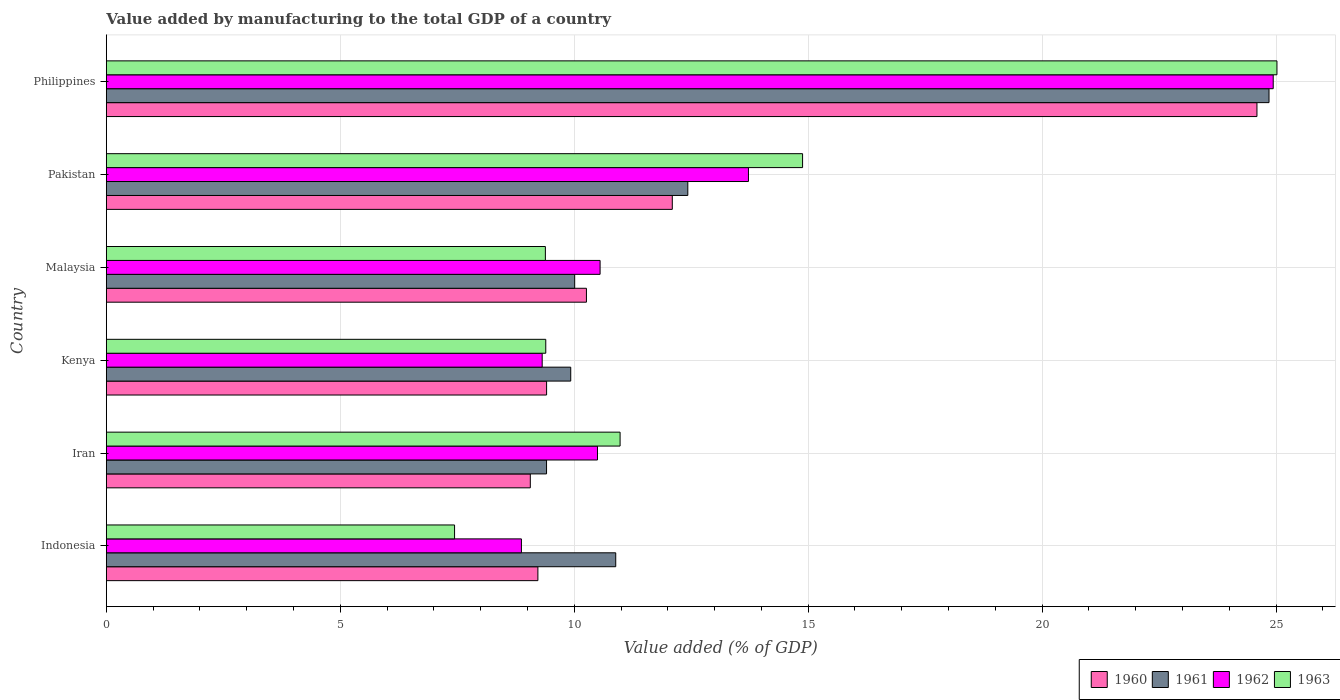How many groups of bars are there?
Keep it short and to the point. 6. How many bars are there on the 2nd tick from the top?
Make the answer very short. 4. What is the label of the 3rd group of bars from the top?
Keep it short and to the point. Malaysia. What is the value added by manufacturing to the total GDP in 1961 in Malaysia?
Make the answer very short. 10.01. Across all countries, what is the maximum value added by manufacturing to the total GDP in 1960?
Ensure brevity in your answer.  24.59. Across all countries, what is the minimum value added by manufacturing to the total GDP in 1961?
Provide a short and direct response. 9.41. In which country was the value added by manufacturing to the total GDP in 1960 maximum?
Your answer should be compact. Philippines. In which country was the value added by manufacturing to the total GDP in 1960 minimum?
Offer a terse response. Iran. What is the total value added by manufacturing to the total GDP in 1962 in the graph?
Offer a very short reply. 77.9. What is the difference between the value added by manufacturing to the total GDP in 1963 in Pakistan and that in Philippines?
Give a very brief answer. -10.14. What is the difference between the value added by manufacturing to the total GDP in 1963 in Iran and the value added by manufacturing to the total GDP in 1962 in Philippines?
Keep it short and to the point. -13.96. What is the average value added by manufacturing to the total GDP in 1961 per country?
Give a very brief answer. 12.92. What is the difference between the value added by manufacturing to the total GDP in 1963 and value added by manufacturing to the total GDP in 1962 in Philippines?
Ensure brevity in your answer.  0.08. In how many countries, is the value added by manufacturing to the total GDP in 1963 greater than 6 %?
Make the answer very short. 6. What is the ratio of the value added by manufacturing to the total GDP in 1962 in Pakistan to that in Philippines?
Ensure brevity in your answer.  0.55. What is the difference between the highest and the second highest value added by manufacturing to the total GDP in 1962?
Your answer should be very brief. 11.22. What is the difference between the highest and the lowest value added by manufacturing to the total GDP in 1963?
Ensure brevity in your answer.  17.58. Is it the case that in every country, the sum of the value added by manufacturing to the total GDP in 1963 and value added by manufacturing to the total GDP in 1961 is greater than the sum of value added by manufacturing to the total GDP in 1962 and value added by manufacturing to the total GDP in 1960?
Keep it short and to the point. No. What does the 1st bar from the top in Iran represents?
Keep it short and to the point. 1963. What does the 2nd bar from the bottom in Kenya represents?
Provide a succinct answer. 1961. Is it the case that in every country, the sum of the value added by manufacturing to the total GDP in 1960 and value added by manufacturing to the total GDP in 1961 is greater than the value added by manufacturing to the total GDP in 1963?
Provide a succinct answer. Yes. Are all the bars in the graph horizontal?
Your answer should be compact. Yes. What is the difference between two consecutive major ticks on the X-axis?
Your answer should be compact. 5. Are the values on the major ticks of X-axis written in scientific E-notation?
Offer a very short reply. No. Does the graph contain grids?
Your answer should be compact. Yes. Where does the legend appear in the graph?
Provide a succinct answer. Bottom right. How many legend labels are there?
Ensure brevity in your answer.  4. How are the legend labels stacked?
Keep it short and to the point. Horizontal. What is the title of the graph?
Make the answer very short. Value added by manufacturing to the total GDP of a country. Does "2000" appear as one of the legend labels in the graph?
Provide a succinct answer. No. What is the label or title of the X-axis?
Provide a succinct answer. Value added (% of GDP). What is the label or title of the Y-axis?
Provide a succinct answer. Country. What is the Value added (% of GDP) in 1960 in Indonesia?
Provide a succinct answer. 9.22. What is the Value added (% of GDP) of 1961 in Indonesia?
Your answer should be compact. 10.89. What is the Value added (% of GDP) in 1962 in Indonesia?
Your response must be concise. 8.87. What is the Value added (% of GDP) in 1963 in Indonesia?
Provide a short and direct response. 7.44. What is the Value added (% of GDP) in 1960 in Iran?
Provide a succinct answer. 9.06. What is the Value added (% of GDP) in 1961 in Iran?
Provide a short and direct response. 9.41. What is the Value added (% of GDP) in 1962 in Iran?
Your answer should be compact. 10.5. What is the Value added (% of GDP) of 1963 in Iran?
Ensure brevity in your answer.  10.98. What is the Value added (% of GDP) in 1960 in Kenya?
Offer a terse response. 9.41. What is the Value added (% of GDP) in 1961 in Kenya?
Give a very brief answer. 9.93. What is the Value added (% of GDP) of 1962 in Kenya?
Offer a very short reply. 9.32. What is the Value added (% of GDP) in 1963 in Kenya?
Give a very brief answer. 9.39. What is the Value added (% of GDP) of 1960 in Malaysia?
Provide a succinct answer. 10.26. What is the Value added (% of GDP) in 1961 in Malaysia?
Your response must be concise. 10.01. What is the Value added (% of GDP) in 1962 in Malaysia?
Your response must be concise. 10.55. What is the Value added (% of GDP) of 1963 in Malaysia?
Keep it short and to the point. 9.38. What is the Value added (% of GDP) of 1960 in Pakistan?
Keep it short and to the point. 12.1. What is the Value added (% of GDP) of 1961 in Pakistan?
Provide a succinct answer. 12.43. What is the Value added (% of GDP) of 1962 in Pakistan?
Ensure brevity in your answer.  13.72. What is the Value added (% of GDP) in 1963 in Pakistan?
Keep it short and to the point. 14.88. What is the Value added (% of GDP) of 1960 in Philippines?
Provide a succinct answer. 24.59. What is the Value added (% of GDP) in 1961 in Philippines?
Your answer should be compact. 24.85. What is the Value added (% of GDP) of 1962 in Philippines?
Your answer should be very brief. 24.94. What is the Value added (% of GDP) in 1963 in Philippines?
Your answer should be very brief. 25.02. Across all countries, what is the maximum Value added (% of GDP) of 1960?
Keep it short and to the point. 24.59. Across all countries, what is the maximum Value added (% of GDP) in 1961?
Keep it short and to the point. 24.85. Across all countries, what is the maximum Value added (% of GDP) of 1962?
Ensure brevity in your answer.  24.94. Across all countries, what is the maximum Value added (% of GDP) in 1963?
Your answer should be very brief. 25.02. Across all countries, what is the minimum Value added (% of GDP) of 1960?
Provide a succinct answer. 9.06. Across all countries, what is the minimum Value added (% of GDP) in 1961?
Keep it short and to the point. 9.41. Across all countries, what is the minimum Value added (% of GDP) in 1962?
Keep it short and to the point. 8.87. Across all countries, what is the minimum Value added (% of GDP) in 1963?
Your answer should be very brief. 7.44. What is the total Value added (% of GDP) of 1960 in the graph?
Ensure brevity in your answer.  74.64. What is the total Value added (% of GDP) in 1961 in the graph?
Make the answer very short. 77.51. What is the total Value added (% of GDP) of 1962 in the graph?
Your response must be concise. 77.9. What is the total Value added (% of GDP) of 1963 in the graph?
Offer a very short reply. 77.1. What is the difference between the Value added (% of GDP) in 1960 in Indonesia and that in Iran?
Give a very brief answer. 0.16. What is the difference between the Value added (% of GDP) of 1961 in Indonesia and that in Iran?
Ensure brevity in your answer.  1.48. What is the difference between the Value added (% of GDP) of 1962 in Indonesia and that in Iran?
Offer a terse response. -1.63. What is the difference between the Value added (% of GDP) in 1963 in Indonesia and that in Iran?
Your answer should be very brief. -3.54. What is the difference between the Value added (% of GDP) in 1960 in Indonesia and that in Kenya?
Make the answer very short. -0.19. What is the difference between the Value added (% of GDP) in 1961 in Indonesia and that in Kenya?
Offer a very short reply. 0.96. What is the difference between the Value added (% of GDP) in 1962 in Indonesia and that in Kenya?
Give a very brief answer. -0.44. What is the difference between the Value added (% of GDP) of 1963 in Indonesia and that in Kenya?
Provide a succinct answer. -1.95. What is the difference between the Value added (% of GDP) of 1960 in Indonesia and that in Malaysia?
Your answer should be very brief. -1.04. What is the difference between the Value added (% of GDP) of 1961 in Indonesia and that in Malaysia?
Your response must be concise. 0.88. What is the difference between the Value added (% of GDP) of 1962 in Indonesia and that in Malaysia?
Keep it short and to the point. -1.68. What is the difference between the Value added (% of GDP) in 1963 in Indonesia and that in Malaysia?
Your response must be concise. -1.94. What is the difference between the Value added (% of GDP) of 1960 in Indonesia and that in Pakistan?
Offer a very short reply. -2.87. What is the difference between the Value added (% of GDP) of 1961 in Indonesia and that in Pakistan?
Your response must be concise. -1.54. What is the difference between the Value added (% of GDP) in 1962 in Indonesia and that in Pakistan?
Make the answer very short. -4.85. What is the difference between the Value added (% of GDP) of 1963 in Indonesia and that in Pakistan?
Make the answer very short. -7.44. What is the difference between the Value added (% of GDP) in 1960 in Indonesia and that in Philippines?
Provide a succinct answer. -15.37. What is the difference between the Value added (% of GDP) of 1961 in Indonesia and that in Philippines?
Provide a short and direct response. -13.96. What is the difference between the Value added (% of GDP) of 1962 in Indonesia and that in Philippines?
Offer a very short reply. -16.07. What is the difference between the Value added (% of GDP) of 1963 in Indonesia and that in Philippines?
Offer a very short reply. -17.58. What is the difference between the Value added (% of GDP) of 1960 in Iran and that in Kenya?
Give a very brief answer. -0.35. What is the difference between the Value added (% of GDP) of 1961 in Iran and that in Kenya?
Offer a terse response. -0.52. What is the difference between the Value added (% of GDP) in 1962 in Iran and that in Kenya?
Offer a very short reply. 1.18. What is the difference between the Value added (% of GDP) in 1963 in Iran and that in Kenya?
Make the answer very short. 1.59. What is the difference between the Value added (% of GDP) of 1960 in Iran and that in Malaysia?
Give a very brief answer. -1.2. What is the difference between the Value added (% of GDP) of 1961 in Iran and that in Malaysia?
Provide a short and direct response. -0.6. What is the difference between the Value added (% of GDP) of 1962 in Iran and that in Malaysia?
Your answer should be very brief. -0.06. What is the difference between the Value added (% of GDP) in 1963 in Iran and that in Malaysia?
Your response must be concise. 1.6. What is the difference between the Value added (% of GDP) in 1960 in Iran and that in Pakistan?
Ensure brevity in your answer.  -3.03. What is the difference between the Value added (% of GDP) of 1961 in Iran and that in Pakistan?
Ensure brevity in your answer.  -3.02. What is the difference between the Value added (% of GDP) in 1962 in Iran and that in Pakistan?
Provide a succinct answer. -3.23. What is the difference between the Value added (% of GDP) in 1960 in Iran and that in Philippines?
Ensure brevity in your answer.  -15.53. What is the difference between the Value added (% of GDP) in 1961 in Iran and that in Philippines?
Provide a succinct answer. -15.44. What is the difference between the Value added (% of GDP) of 1962 in Iran and that in Philippines?
Provide a short and direct response. -14.44. What is the difference between the Value added (% of GDP) of 1963 in Iran and that in Philippines?
Your response must be concise. -14.04. What is the difference between the Value added (% of GDP) in 1960 in Kenya and that in Malaysia?
Give a very brief answer. -0.85. What is the difference between the Value added (% of GDP) of 1961 in Kenya and that in Malaysia?
Your response must be concise. -0.08. What is the difference between the Value added (% of GDP) in 1962 in Kenya and that in Malaysia?
Your answer should be compact. -1.24. What is the difference between the Value added (% of GDP) in 1963 in Kenya and that in Malaysia?
Your response must be concise. 0.01. What is the difference between the Value added (% of GDP) of 1960 in Kenya and that in Pakistan?
Give a very brief answer. -2.69. What is the difference between the Value added (% of GDP) in 1961 in Kenya and that in Pakistan?
Your answer should be very brief. -2.5. What is the difference between the Value added (% of GDP) of 1962 in Kenya and that in Pakistan?
Provide a short and direct response. -4.41. What is the difference between the Value added (% of GDP) of 1963 in Kenya and that in Pakistan?
Offer a very short reply. -5.49. What is the difference between the Value added (% of GDP) in 1960 in Kenya and that in Philippines?
Offer a very short reply. -15.18. What is the difference between the Value added (% of GDP) in 1961 in Kenya and that in Philippines?
Your answer should be very brief. -14.92. What is the difference between the Value added (% of GDP) of 1962 in Kenya and that in Philippines?
Offer a terse response. -15.62. What is the difference between the Value added (% of GDP) in 1963 in Kenya and that in Philippines?
Your answer should be compact. -15.63. What is the difference between the Value added (% of GDP) in 1960 in Malaysia and that in Pakistan?
Provide a short and direct response. -1.84. What is the difference between the Value added (% of GDP) in 1961 in Malaysia and that in Pakistan?
Your answer should be very brief. -2.42. What is the difference between the Value added (% of GDP) in 1962 in Malaysia and that in Pakistan?
Provide a succinct answer. -3.17. What is the difference between the Value added (% of GDP) of 1963 in Malaysia and that in Pakistan?
Provide a short and direct response. -5.5. What is the difference between the Value added (% of GDP) in 1960 in Malaysia and that in Philippines?
Offer a terse response. -14.33. What is the difference between the Value added (% of GDP) in 1961 in Malaysia and that in Philippines?
Make the answer very short. -14.84. What is the difference between the Value added (% of GDP) of 1962 in Malaysia and that in Philippines?
Ensure brevity in your answer.  -14.39. What is the difference between the Value added (% of GDP) of 1963 in Malaysia and that in Philippines?
Make the answer very short. -15.64. What is the difference between the Value added (% of GDP) of 1960 in Pakistan and that in Philippines?
Your answer should be compact. -12.5. What is the difference between the Value added (% of GDP) of 1961 in Pakistan and that in Philippines?
Keep it short and to the point. -12.42. What is the difference between the Value added (% of GDP) of 1962 in Pakistan and that in Philippines?
Ensure brevity in your answer.  -11.22. What is the difference between the Value added (% of GDP) in 1963 in Pakistan and that in Philippines?
Keep it short and to the point. -10.14. What is the difference between the Value added (% of GDP) in 1960 in Indonesia and the Value added (% of GDP) in 1961 in Iran?
Your answer should be compact. -0.18. What is the difference between the Value added (% of GDP) in 1960 in Indonesia and the Value added (% of GDP) in 1962 in Iran?
Provide a succinct answer. -1.27. What is the difference between the Value added (% of GDP) of 1960 in Indonesia and the Value added (% of GDP) of 1963 in Iran?
Make the answer very short. -1.76. What is the difference between the Value added (% of GDP) of 1961 in Indonesia and the Value added (% of GDP) of 1962 in Iran?
Your response must be concise. 0.39. What is the difference between the Value added (% of GDP) in 1961 in Indonesia and the Value added (% of GDP) in 1963 in Iran?
Your answer should be compact. -0.09. What is the difference between the Value added (% of GDP) of 1962 in Indonesia and the Value added (% of GDP) of 1963 in Iran?
Provide a short and direct response. -2.11. What is the difference between the Value added (% of GDP) of 1960 in Indonesia and the Value added (% of GDP) of 1961 in Kenya?
Make the answer very short. -0.7. What is the difference between the Value added (% of GDP) of 1960 in Indonesia and the Value added (% of GDP) of 1962 in Kenya?
Offer a terse response. -0.09. What is the difference between the Value added (% of GDP) in 1960 in Indonesia and the Value added (% of GDP) in 1963 in Kenya?
Ensure brevity in your answer.  -0.17. What is the difference between the Value added (% of GDP) of 1961 in Indonesia and the Value added (% of GDP) of 1962 in Kenya?
Your answer should be very brief. 1.57. What is the difference between the Value added (% of GDP) in 1961 in Indonesia and the Value added (% of GDP) in 1963 in Kenya?
Make the answer very short. 1.5. What is the difference between the Value added (% of GDP) of 1962 in Indonesia and the Value added (% of GDP) of 1963 in Kenya?
Your response must be concise. -0.52. What is the difference between the Value added (% of GDP) of 1960 in Indonesia and the Value added (% of GDP) of 1961 in Malaysia?
Offer a very short reply. -0.79. What is the difference between the Value added (% of GDP) of 1960 in Indonesia and the Value added (% of GDP) of 1962 in Malaysia?
Offer a terse response. -1.33. What is the difference between the Value added (% of GDP) in 1960 in Indonesia and the Value added (% of GDP) in 1963 in Malaysia?
Ensure brevity in your answer.  -0.16. What is the difference between the Value added (% of GDP) in 1961 in Indonesia and the Value added (% of GDP) in 1962 in Malaysia?
Your answer should be compact. 0.33. What is the difference between the Value added (% of GDP) of 1961 in Indonesia and the Value added (% of GDP) of 1963 in Malaysia?
Your answer should be very brief. 1.5. What is the difference between the Value added (% of GDP) in 1962 in Indonesia and the Value added (% of GDP) in 1963 in Malaysia?
Ensure brevity in your answer.  -0.51. What is the difference between the Value added (% of GDP) in 1960 in Indonesia and the Value added (% of GDP) in 1961 in Pakistan?
Your answer should be compact. -3.2. What is the difference between the Value added (% of GDP) of 1960 in Indonesia and the Value added (% of GDP) of 1962 in Pakistan?
Your answer should be very brief. -4.5. What is the difference between the Value added (% of GDP) of 1960 in Indonesia and the Value added (% of GDP) of 1963 in Pakistan?
Offer a terse response. -5.66. What is the difference between the Value added (% of GDP) of 1961 in Indonesia and the Value added (% of GDP) of 1962 in Pakistan?
Provide a short and direct response. -2.84. What is the difference between the Value added (% of GDP) in 1961 in Indonesia and the Value added (% of GDP) in 1963 in Pakistan?
Offer a terse response. -3.99. What is the difference between the Value added (% of GDP) of 1962 in Indonesia and the Value added (% of GDP) of 1963 in Pakistan?
Make the answer very short. -6.01. What is the difference between the Value added (% of GDP) of 1960 in Indonesia and the Value added (% of GDP) of 1961 in Philippines?
Give a very brief answer. -15.63. What is the difference between the Value added (% of GDP) in 1960 in Indonesia and the Value added (% of GDP) in 1962 in Philippines?
Give a very brief answer. -15.72. What is the difference between the Value added (% of GDP) of 1960 in Indonesia and the Value added (% of GDP) of 1963 in Philippines?
Offer a terse response. -15.8. What is the difference between the Value added (% of GDP) in 1961 in Indonesia and the Value added (% of GDP) in 1962 in Philippines?
Your answer should be very brief. -14.05. What is the difference between the Value added (% of GDP) of 1961 in Indonesia and the Value added (% of GDP) of 1963 in Philippines?
Provide a succinct answer. -14.13. What is the difference between the Value added (% of GDP) of 1962 in Indonesia and the Value added (% of GDP) of 1963 in Philippines?
Your answer should be very brief. -16.15. What is the difference between the Value added (% of GDP) of 1960 in Iran and the Value added (% of GDP) of 1961 in Kenya?
Provide a short and direct response. -0.86. What is the difference between the Value added (% of GDP) of 1960 in Iran and the Value added (% of GDP) of 1962 in Kenya?
Give a very brief answer. -0.25. What is the difference between the Value added (% of GDP) of 1960 in Iran and the Value added (% of GDP) of 1963 in Kenya?
Offer a very short reply. -0.33. What is the difference between the Value added (% of GDP) in 1961 in Iran and the Value added (% of GDP) in 1962 in Kenya?
Offer a terse response. 0.09. What is the difference between the Value added (% of GDP) in 1961 in Iran and the Value added (% of GDP) in 1963 in Kenya?
Keep it short and to the point. 0.02. What is the difference between the Value added (% of GDP) of 1962 in Iran and the Value added (% of GDP) of 1963 in Kenya?
Offer a very short reply. 1.11. What is the difference between the Value added (% of GDP) in 1960 in Iran and the Value added (% of GDP) in 1961 in Malaysia?
Offer a terse response. -0.95. What is the difference between the Value added (% of GDP) of 1960 in Iran and the Value added (% of GDP) of 1962 in Malaysia?
Ensure brevity in your answer.  -1.49. What is the difference between the Value added (% of GDP) of 1960 in Iran and the Value added (% of GDP) of 1963 in Malaysia?
Offer a terse response. -0.32. What is the difference between the Value added (% of GDP) of 1961 in Iran and the Value added (% of GDP) of 1962 in Malaysia?
Make the answer very short. -1.14. What is the difference between the Value added (% of GDP) in 1961 in Iran and the Value added (% of GDP) in 1963 in Malaysia?
Offer a terse response. 0.03. What is the difference between the Value added (% of GDP) in 1962 in Iran and the Value added (% of GDP) in 1963 in Malaysia?
Make the answer very short. 1.11. What is the difference between the Value added (% of GDP) in 1960 in Iran and the Value added (% of GDP) in 1961 in Pakistan?
Provide a succinct answer. -3.37. What is the difference between the Value added (% of GDP) in 1960 in Iran and the Value added (% of GDP) in 1962 in Pakistan?
Ensure brevity in your answer.  -4.66. What is the difference between the Value added (% of GDP) in 1960 in Iran and the Value added (% of GDP) in 1963 in Pakistan?
Make the answer very short. -5.82. What is the difference between the Value added (% of GDP) of 1961 in Iran and the Value added (% of GDP) of 1962 in Pakistan?
Offer a very short reply. -4.32. What is the difference between the Value added (% of GDP) in 1961 in Iran and the Value added (% of GDP) in 1963 in Pakistan?
Your response must be concise. -5.47. What is the difference between the Value added (% of GDP) of 1962 in Iran and the Value added (% of GDP) of 1963 in Pakistan?
Offer a terse response. -4.38. What is the difference between the Value added (% of GDP) in 1960 in Iran and the Value added (% of GDP) in 1961 in Philippines?
Ensure brevity in your answer.  -15.79. What is the difference between the Value added (% of GDP) of 1960 in Iran and the Value added (% of GDP) of 1962 in Philippines?
Offer a very short reply. -15.88. What is the difference between the Value added (% of GDP) of 1960 in Iran and the Value added (% of GDP) of 1963 in Philippines?
Make the answer very short. -15.96. What is the difference between the Value added (% of GDP) in 1961 in Iran and the Value added (% of GDP) in 1962 in Philippines?
Provide a short and direct response. -15.53. What is the difference between the Value added (% of GDP) in 1961 in Iran and the Value added (% of GDP) in 1963 in Philippines?
Your answer should be very brief. -15.61. What is the difference between the Value added (% of GDP) in 1962 in Iran and the Value added (% of GDP) in 1963 in Philippines?
Your response must be concise. -14.52. What is the difference between the Value added (% of GDP) of 1960 in Kenya and the Value added (% of GDP) of 1961 in Malaysia?
Your response must be concise. -0.6. What is the difference between the Value added (% of GDP) in 1960 in Kenya and the Value added (% of GDP) in 1962 in Malaysia?
Give a very brief answer. -1.14. What is the difference between the Value added (% of GDP) in 1960 in Kenya and the Value added (% of GDP) in 1963 in Malaysia?
Provide a short and direct response. 0.03. What is the difference between the Value added (% of GDP) in 1961 in Kenya and the Value added (% of GDP) in 1962 in Malaysia?
Provide a short and direct response. -0.63. What is the difference between the Value added (% of GDP) in 1961 in Kenya and the Value added (% of GDP) in 1963 in Malaysia?
Your answer should be compact. 0.54. What is the difference between the Value added (% of GDP) in 1962 in Kenya and the Value added (% of GDP) in 1963 in Malaysia?
Make the answer very short. -0.07. What is the difference between the Value added (% of GDP) in 1960 in Kenya and the Value added (% of GDP) in 1961 in Pakistan?
Your answer should be very brief. -3.02. What is the difference between the Value added (% of GDP) in 1960 in Kenya and the Value added (% of GDP) in 1962 in Pakistan?
Give a very brief answer. -4.31. What is the difference between the Value added (% of GDP) of 1960 in Kenya and the Value added (% of GDP) of 1963 in Pakistan?
Keep it short and to the point. -5.47. What is the difference between the Value added (% of GDP) of 1961 in Kenya and the Value added (% of GDP) of 1962 in Pakistan?
Offer a terse response. -3.8. What is the difference between the Value added (% of GDP) in 1961 in Kenya and the Value added (% of GDP) in 1963 in Pakistan?
Offer a terse response. -4.96. What is the difference between the Value added (% of GDP) of 1962 in Kenya and the Value added (% of GDP) of 1963 in Pakistan?
Provide a short and direct response. -5.57. What is the difference between the Value added (% of GDP) of 1960 in Kenya and the Value added (% of GDP) of 1961 in Philippines?
Offer a terse response. -15.44. What is the difference between the Value added (% of GDP) of 1960 in Kenya and the Value added (% of GDP) of 1962 in Philippines?
Offer a very short reply. -15.53. What is the difference between the Value added (% of GDP) in 1960 in Kenya and the Value added (% of GDP) in 1963 in Philippines?
Your answer should be compact. -15.61. What is the difference between the Value added (% of GDP) of 1961 in Kenya and the Value added (% of GDP) of 1962 in Philippines?
Make the answer very short. -15.01. What is the difference between the Value added (% of GDP) of 1961 in Kenya and the Value added (% of GDP) of 1963 in Philippines?
Keep it short and to the point. -15.09. What is the difference between the Value added (% of GDP) in 1962 in Kenya and the Value added (% of GDP) in 1963 in Philippines?
Provide a succinct answer. -15.7. What is the difference between the Value added (% of GDP) in 1960 in Malaysia and the Value added (% of GDP) in 1961 in Pakistan?
Give a very brief answer. -2.17. What is the difference between the Value added (% of GDP) in 1960 in Malaysia and the Value added (% of GDP) in 1962 in Pakistan?
Make the answer very short. -3.46. What is the difference between the Value added (% of GDP) of 1960 in Malaysia and the Value added (% of GDP) of 1963 in Pakistan?
Your response must be concise. -4.62. What is the difference between the Value added (% of GDP) in 1961 in Malaysia and the Value added (% of GDP) in 1962 in Pakistan?
Keep it short and to the point. -3.71. What is the difference between the Value added (% of GDP) in 1961 in Malaysia and the Value added (% of GDP) in 1963 in Pakistan?
Keep it short and to the point. -4.87. What is the difference between the Value added (% of GDP) in 1962 in Malaysia and the Value added (% of GDP) in 1963 in Pakistan?
Offer a very short reply. -4.33. What is the difference between the Value added (% of GDP) in 1960 in Malaysia and the Value added (% of GDP) in 1961 in Philippines?
Offer a terse response. -14.59. What is the difference between the Value added (% of GDP) of 1960 in Malaysia and the Value added (% of GDP) of 1962 in Philippines?
Your answer should be very brief. -14.68. What is the difference between the Value added (% of GDP) in 1960 in Malaysia and the Value added (% of GDP) in 1963 in Philippines?
Give a very brief answer. -14.76. What is the difference between the Value added (% of GDP) in 1961 in Malaysia and the Value added (% of GDP) in 1962 in Philippines?
Provide a short and direct response. -14.93. What is the difference between the Value added (% of GDP) in 1961 in Malaysia and the Value added (% of GDP) in 1963 in Philippines?
Provide a succinct answer. -15.01. What is the difference between the Value added (% of GDP) in 1962 in Malaysia and the Value added (% of GDP) in 1963 in Philippines?
Provide a short and direct response. -14.47. What is the difference between the Value added (% of GDP) of 1960 in Pakistan and the Value added (% of GDP) of 1961 in Philippines?
Give a very brief answer. -12.75. What is the difference between the Value added (% of GDP) in 1960 in Pakistan and the Value added (% of GDP) in 1962 in Philippines?
Give a very brief answer. -12.84. What is the difference between the Value added (% of GDP) of 1960 in Pakistan and the Value added (% of GDP) of 1963 in Philippines?
Provide a short and direct response. -12.92. What is the difference between the Value added (% of GDP) in 1961 in Pakistan and the Value added (% of GDP) in 1962 in Philippines?
Give a very brief answer. -12.51. What is the difference between the Value added (% of GDP) of 1961 in Pakistan and the Value added (% of GDP) of 1963 in Philippines?
Provide a succinct answer. -12.59. What is the difference between the Value added (% of GDP) of 1962 in Pakistan and the Value added (% of GDP) of 1963 in Philippines?
Your answer should be very brief. -11.3. What is the average Value added (% of GDP) of 1960 per country?
Provide a short and direct response. 12.44. What is the average Value added (% of GDP) of 1961 per country?
Give a very brief answer. 12.92. What is the average Value added (% of GDP) of 1962 per country?
Make the answer very short. 12.98. What is the average Value added (% of GDP) of 1963 per country?
Offer a terse response. 12.85. What is the difference between the Value added (% of GDP) in 1960 and Value added (% of GDP) in 1961 in Indonesia?
Ensure brevity in your answer.  -1.66. What is the difference between the Value added (% of GDP) of 1960 and Value added (% of GDP) of 1962 in Indonesia?
Your answer should be very brief. 0.35. What is the difference between the Value added (% of GDP) of 1960 and Value added (% of GDP) of 1963 in Indonesia?
Offer a terse response. 1.78. What is the difference between the Value added (% of GDP) in 1961 and Value added (% of GDP) in 1962 in Indonesia?
Ensure brevity in your answer.  2.02. What is the difference between the Value added (% of GDP) in 1961 and Value added (% of GDP) in 1963 in Indonesia?
Keep it short and to the point. 3.44. What is the difference between the Value added (% of GDP) in 1962 and Value added (% of GDP) in 1963 in Indonesia?
Make the answer very short. 1.43. What is the difference between the Value added (% of GDP) in 1960 and Value added (% of GDP) in 1961 in Iran?
Your response must be concise. -0.35. What is the difference between the Value added (% of GDP) of 1960 and Value added (% of GDP) of 1962 in Iran?
Offer a very short reply. -1.44. What is the difference between the Value added (% of GDP) of 1960 and Value added (% of GDP) of 1963 in Iran?
Your response must be concise. -1.92. What is the difference between the Value added (% of GDP) of 1961 and Value added (% of GDP) of 1962 in Iran?
Your answer should be very brief. -1.09. What is the difference between the Value added (% of GDP) in 1961 and Value added (% of GDP) in 1963 in Iran?
Make the answer very short. -1.57. What is the difference between the Value added (% of GDP) in 1962 and Value added (% of GDP) in 1963 in Iran?
Ensure brevity in your answer.  -0.48. What is the difference between the Value added (% of GDP) of 1960 and Value added (% of GDP) of 1961 in Kenya?
Give a very brief answer. -0.52. What is the difference between the Value added (% of GDP) of 1960 and Value added (% of GDP) of 1962 in Kenya?
Offer a terse response. 0.09. What is the difference between the Value added (% of GDP) of 1960 and Value added (% of GDP) of 1963 in Kenya?
Give a very brief answer. 0.02. What is the difference between the Value added (% of GDP) of 1961 and Value added (% of GDP) of 1962 in Kenya?
Make the answer very short. 0.61. What is the difference between the Value added (% of GDP) in 1961 and Value added (% of GDP) in 1963 in Kenya?
Your answer should be very brief. 0.53. What is the difference between the Value added (% of GDP) of 1962 and Value added (% of GDP) of 1963 in Kenya?
Your answer should be very brief. -0.08. What is the difference between the Value added (% of GDP) of 1960 and Value added (% of GDP) of 1961 in Malaysia?
Provide a succinct answer. 0.25. What is the difference between the Value added (% of GDP) in 1960 and Value added (% of GDP) in 1962 in Malaysia?
Give a very brief answer. -0.29. What is the difference between the Value added (% of GDP) of 1960 and Value added (% of GDP) of 1963 in Malaysia?
Your answer should be very brief. 0.88. What is the difference between the Value added (% of GDP) in 1961 and Value added (% of GDP) in 1962 in Malaysia?
Your answer should be compact. -0.54. What is the difference between the Value added (% of GDP) in 1961 and Value added (% of GDP) in 1963 in Malaysia?
Your answer should be very brief. 0.63. What is the difference between the Value added (% of GDP) of 1962 and Value added (% of GDP) of 1963 in Malaysia?
Give a very brief answer. 1.17. What is the difference between the Value added (% of GDP) in 1960 and Value added (% of GDP) in 1961 in Pakistan?
Your answer should be compact. -0.33. What is the difference between the Value added (% of GDP) in 1960 and Value added (% of GDP) in 1962 in Pakistan?
Ensure brevity in your answer.  -1.63. What is the difference between the Value added (% of GDP) of 1960 and Value added (% of GDP) of 1963 in Pakistan?
Your answer should be compact. -2.78. What is the difference between the Value added (% of GDP) in 1961 and Value added (% of GDP) in 1962 in Pakistan?
Your answer should be very brief. -1.3. What is the difference between the Value added (% of GDP) in 1961 and Value added (% of GDP) in 1963 in Pakistan?
Offer a very short reply. -2.45. What is the difference between the Value added (% of GDP) in 1962 and Value added (% of GDP) in 1963 in Pakistan?
Keep it short and to the point. -1.16. What is the difference between the Value added (% of GDP) in 1960 and Value added (% of GDP) in 1961 in Philippines?
Provide a succinct answer. -0.26. What is the difference between the Value added (% of GDP) of 1960 and Value added (% of GDP) of 1962 in Philippines?
Provide a succinct answer. -0.35. What is the difference between the Value added (% of GDP) in 1960 and Value added (% of GDP) in 1963 in Philippines?
Offer a very short reply. -0.43. What is the difference between the Value added (% of GDP) of 1961 and Value added (% of GDP) of 1962 in Philippines?
Your answer should be very brief. -0.09. What is the difference between the Value added (% of GDP) of 1961 and Value added (% of GDP) of 1963 in Philippines?
Offer a very short reply. -0.17. What is the difference between the Value added (% of GDP) of 1962 and Value added (% of GDP) of 1963 in Philippines?
Make the answer very short. -0.08. What is the ratio of the Value added (% of GDP) of 1960 in Indonesia to that in Iran?
Give a very brief answer. 1.02. What is the ratio of the Value added (% of GDP) of 1961 in Indonesia to that in Iran?
Your response must be concise. 1.16. What is the ratio of the Value added (% of GDP) in 1962 in Indonesia to that in Iran?
Make the answer very short. 0.85. What is the ratio of the Value added (% of GDP) in 1963 in Indonesia to that in Iran?
Your answer should be very brief. 0.68. What is the ratio of the Value added (% of GDP) in 1960 in Indonesia to that in Kenya?
Ensure brevity in your answer.  0.98. What is the ratio of the Value added (% of GDP) of 1961 in Indonesia to that in Kenya?
Make the answer very short. 1.1. What is the ratio of the Value added (% of GDP) of 1963 in Indonesia to that in Kenya?
Provide a short and direct response. 0.79. What is the ratio of the Value added (% of GDP) of 1960 in Indonesia to that in Malaysia?
Your answer should be compact. 0.9. What is the ratio of the Value added (% of GDP) in 1961 in Indonesia to that in Malaysia?
Make the answer very short. 1.09. What is the ratio of the Value added (% of GDP) of 1962 in Indonesia to that in Malaysia?
Ensure brevity in your answer.  0.84. What is the ratio of the Value added (% of GDP) of 1963 in Indonesia to that in Malaysia?
Give a very brief answer. 0.79. What is the ratio of the Value added (% of GDP) of 1960 in Indonesia to that in Pakistan?
Your answer should be compact. 0.76. What is the ratio of the Value added (% of GDP) of 1961 in Indonesia to that in Pakistan?
Keep it short and to the point. 0.88. What is the ratio of the Value added (% of GDP) of 1962 in Indonesia to that in Pakistan?
Give a very brief answer. 0.65. What is the ratio of the Value added (% of GDP) in 1963 in Indonesia to that in Pakistan?
Your response must be concise. 0.5. What is the ratio of the Value added (% of GDP) in 1960 in Indonesia to that in Philippines?
Make the answer very short. 0.38. What is the ratio of the Value added (% of GDP) in 1961 in Indonesia to that in Philippines?
Ensure brevity in your answer.  0.44. What is the ratio of the Value added (% of GDP) of 1962 in Indonesia to that in Philippines?
Your answer should be very brief. 0.36. What is the ratio of the Value added (% of GDP) in 1963 in Indonesia to that in Philippines?
Your answer should be compact. 0.3. What is the ratio of the Value added (% of GDP) in 1961 in Iran to that in Kenya?
Your response must be concise. 0.95. What is the ratio of the Value added (% of GDP) of 1962 in Iran to that in Kenya?
Ensure brevity in your answer.  1.13. What is the ratio of the Value added (% of GDP) in 1963 in Iran to that in Kenya?
Your response must be concise. 1.17. What is the ratio of the Value added (% of GDP) in 1960 in Iran to that in Malaysia?
Make the answer very short. 0.88. What is the ratio of the Value added (% of GDP) of 1961 in Iran to that in Malaysia?
Ensure brevity in your answer.  0.94. What is the ratio of the Value added (% of GDP) of 1962 in Iran to that in Malaysia?
Make the answer very short. 0.99. What is the ratio of the Value added (% of GDP) of 1963 in Iran to that in Malaysia?
Offer a terse response. 1.17. What is the ratio of the Value added (% of GDP) in 1960 in Iran to that in Pakistan?
Provide a short and direct response. 0.75. What is the ratio of the Value added (% of GDP) of 1961 in Iran to that in Pakistan?
Keep it short and to the point. 0.76. What is the ratio of the Value added (% of GDP) in 1962 in Iran to that in Pakistan?
Your answer should be compact. 0.76. What is the ratio of the Value added (% of GDP) of 1963 in Iran to that in Pakistan?
Your answer should be very brief. 0.74. What is the ratio of the Value added (% of GDP) of 1960 in Iran to that in Philippines?
Your answer should be very brief. 0.37. What is the ratio of the Value added (% of GDP) of 1961 in Iran to that in Philippines?
Provide a succinct answer. 0.38. What is the ratio of the Value added (% of GDP) in 1962 in Iran to that in Philippines?
Provide a succinct answer. 0.42. What is the ratio of the Value added (% of GDP) of 1963 in Iran to that in Philippines?
Your response must be concise. 0.44. What is the ratio of the Value added (% of GDP) in 1960 in Kenya to that in Malaysia?
Provide a succinct answer. 0.92. What is the ratio of the Value added (% of GDP) of 1962 in Kenya to that in Malaysia?
Provide a short and direct response. 0.88. What is the ratio of the Value added (% of GDP) of 1960 in Kenya to that in Pakistan?
Provide a succinct answer. 0.78. What is the ratio of the Value added (% of GDP) in 1961 in Kenya to that in Pakistan?
Ensure brevity in your answer.  0.8. What is the ratio of the Value added (% of GDP) of 1962 in Kenya to that in Pakistan?
Keep it short and to the point. 0.68. What is the ratio of the Value added (% of GDP) in 1963 in Kenya to that in Pakistan?
Ensure brevity in your answer.  0.63. What is the ratio of the Value added (% of GDP) of 1960 in Kenya to that in Philippines?
Offer a terse response. 0.38. What is the ratio of the Value added (% of GDP) in 1961 in Kenya to that in Philippines?
Ensure brevity in your answer.  0.4. What is the ratio of the Value added (% of GDP) in 1962 in Kenya to that in Philippines?
Offer a terse response. 0.37. What is the ratio of the Value added (% of GDP) in 1963 in Kenya to that in Philippines?
Make the answer very short. 0.38. What is the ratio of the Value added (% of GDP) in 1960 in Malaysia to that in Pakistan?
Your response must be concise. 0.85. What is the ratio of the Value added (% of GDP) of 1961 in Malaysia to that in Pakistan?
Provide a short and direct response. 0.81. What is the ratio of the Value added (% of GDP) of 1962 in Malaysia to that in Pakistan?
Provide a succinct answer. 0.77. What is the ratio of the Value added (% of GDP) in 1963 in Malaysia to that in Pakistan?
Your answer should be very brief. 0.63. What is the ratio of the Value added (% of GDP) of 1960 in Malaysia to that in Philippines?
Keep it short and to the point. 0.42. What is the ratio of the Value added (% of GDP) in 1961 in Malaysia to that in Philippines?
Offer a very short reply. 0.4. What is the ratio of the Value added (% of GDP) of 1962 in Malaysia to that in Philippines?
Offer a terse response. 0.42. What is the ratio of the Value added (% of GDP) of 1963 in Malaysia to that in Philippines?
Keep it short and to the point. 0.38. What is the ratio of the Value added (% of GDP) of 1960 in Pakistan to that in Philippines?
Provide a succinct answer. 0.49. What is the ratio of the Value added (% of GDP) in 1961 in Pakistan to that in Philippines?
Provide a short and direct response. 0.5. What is the ratio of the Value added (% of GDP) in 1962 in Pakistan to that in Philippines?
Offer a terse response. 0.55. What is the ratio of the Value added (% of GDP) of 1963 in Pakistan to that in Philippines?
Provide a short and direct response. 0.59. What is the difference between the highest and the second highest Value added (% of GDP) of 1960?
Keep it short and to the point. 12.5. What is the difference between the highest and the second highest Value added (% of GDP) in 1961?
Keep it short and to the point. 12.42. What is the difference between the highest and the second highest Value added (% of GDP) in 1962?
Offer a very short reply. 11.22. What is the difference between the highest and the second highest Value added (% of GDP) of 1963?
Your answer should be compact. 10.14. What is the difference between the highest and the lowest Value added (% of GDP) in 1960?
Provide a short and direct response. 15.53. What is the difference between the highest and the lowest Value added (% of GDP) of 1961?
Your answer should be compact. 15.44. What is the difference between the highest and the lowest Value added (% of GDP) of 1962?
Make the answer very short. 16.07. What is the difference between the highest and the lowest Value added (% of GDP) of 1963?
Offer a very short reply. 17.58. 